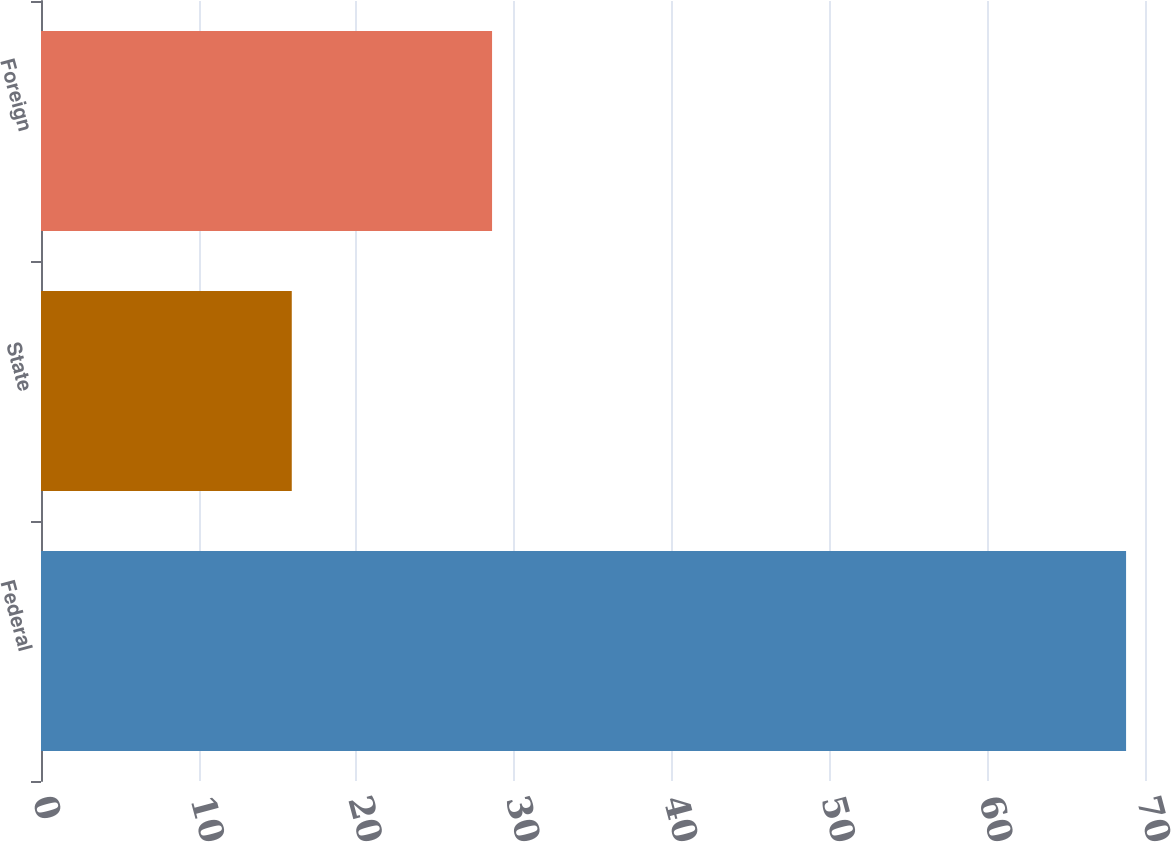Convert chart to OTSL. <chart><loc_0><loc_0><loc_500><loc_500><bar_chart><fcel>Federal<fcel>State<fcel>Foreign<nl><fcel>68.8<fcel>15.9<fcel>28.6<nl></chart> 